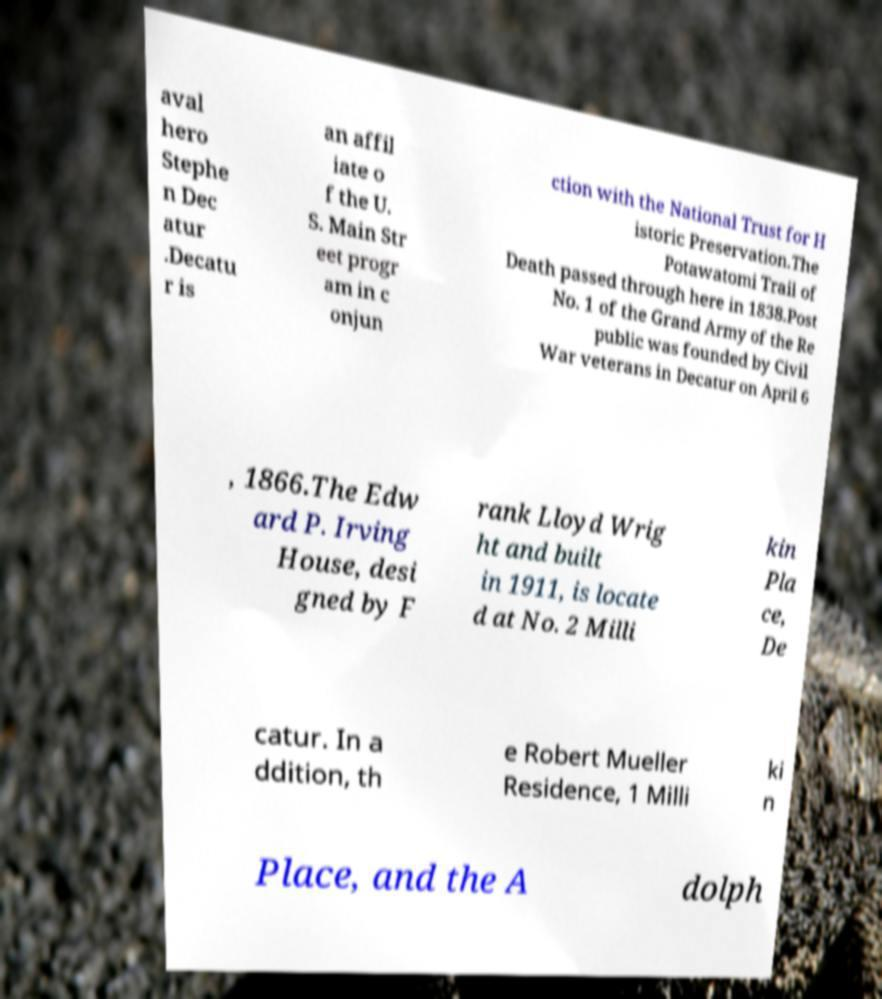Please read and relay the text visible in this image. What does it say? aval hero Stephe n Dec atur .Decatu r is an affil iate o f the U. S. Main Str eet progr am in c onjun ction with the National Trust for H istoric Preservation.The Potawatomi Trail of Death passed through here in 1838.Post No. 1 of the Grand Army of the Re public was founded by Civil War veterans in Decatur on April 6 , 1866.The Edw ard P. Irving House, desi gned by F rank Lloyd Wrig ht and built in 1911, is locate d at No. 2 Milli kin Pla ce, De catur. In a ddition, th e Robert Mueller Residence, 1 Milli ki n Place, and the A dolph 